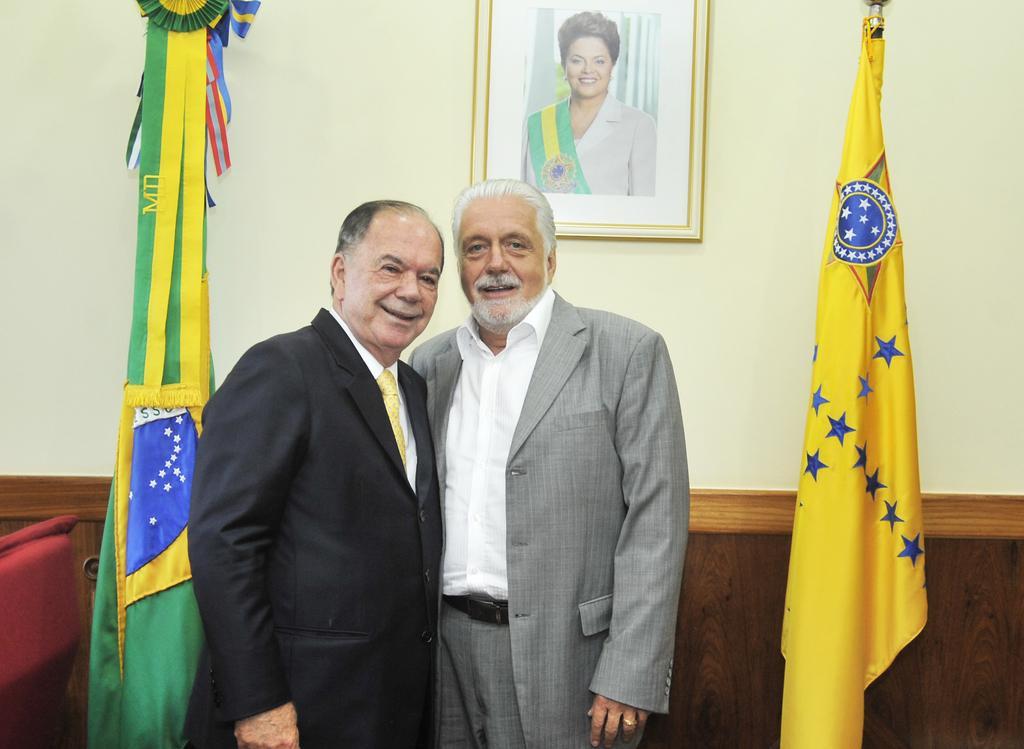In one or two sentences, can you explain what this image depicts? In the picture I can see two men are standing and smiling. These men are wearing coats. In the background I can see a photo frame attached to the wall. I can also see flags and some other objects. 